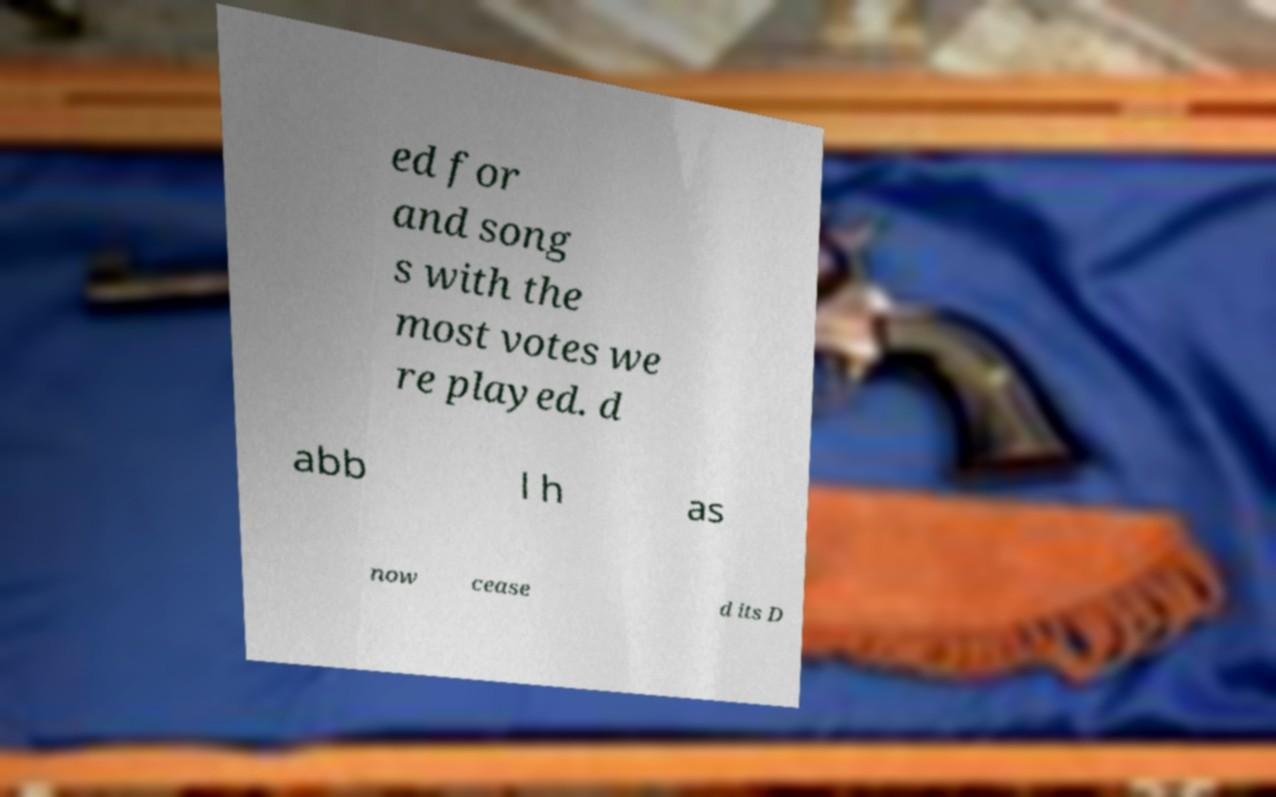Can you accurately transcribe the text from the provided image for me? ed for and song s with the most votes we re played. d abb l h as now cease d its D 